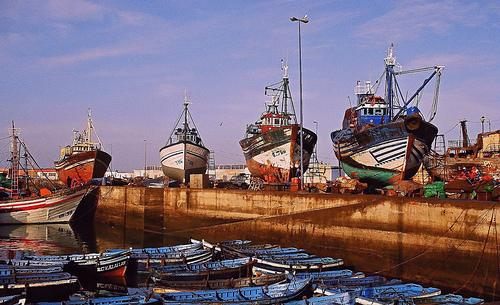Count the number of fishing boats in the image. There are five fishing boats in the image: one red, one white and red, one white, and two other smaller ones. How do the weather conditions in the image seem? The weather conditions in the image seem pleasant, with a blue sky and some scattered clouds, indicating a calm day. Explain the presence of one object in the image and its significance to the scene. The tall cement wall is present along the water, functioning as a seawall to protect the docked boats and surrounding structures from potential waves and storms. Identify and describe one visible interaction between objects in the image. A bird is perched on top of the street light on the dock, creating an interaction between the bird and the light pole. What color is the large ship on the right side of the image? The large ship on the right side of the image is blue and white. Evaluate the quality of the objects in the image. The quality of the objects in the image is clear, with well-defined shapes and vibrant colors to distinguish between the objects. Write a headline for a news article based on this image. "Fishing Boats Dock Alongside Seawall: A Colorful Display of Maritime Activity" What emotions or sentiments can be associated with this image? The image evokes feelings of serenity, peacefulness, and a sense of work completed, as the fishing boats are docked. What objects are in the sky in this image? There are clouds in the sky in this image. Provide a one-sentence summary of the scene depicted in the image. Several boats, including fishing and dry-docked, are situated along a large concrete wall in a body of water, under a blue sky with scattered clouds. 1. Can you see a small green and yellow ship in the image? There is no green and yellow ship in the image. There is only a large blue and white ship and a large ship that is mostly red. 3. Can you find a person standing next to the group of small boats? There is no mention of a person standing next to the group of small boats in the image information. 5. Are there mountains in the background of the image? There is no mention of mountains in the background of the image. The only background element mentioned is the blue sky with clouds. 2. Is there a tree near the street light on the dock? There is no mention of a tree near the street light on the dock in the image information. 6. Can you notice any animals on the large concrete wall? There is no mention of animals on the large concrete wall in the image information. 4. Does the white and red fishing boat have a yellow buoy on top of it? There is no mention of a yellow buoy on top of the white and red fishing boat. Instead, there is a red buoy on top of a fishing boat. 